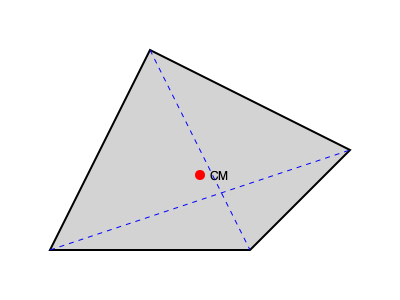An irregularly shaped object is shown above. Two lines are drawn connecting opposite corners. What method can be used to determine the center of mass (CM) of this object, and where would it be located? To determine the center of mass for an irregularly shaped object, we can follow these steps:

1. The method used is the intersection of diagonals for a planar object.

2. For a planar object with uniform density, the center of mass lies at the centroid of the shape.

3. In this case, we draw two lines connecting opposite corners (diagonals) of the irregular quadrilateral.

4. The intersection point of these diagonals represents the centroid, and thus the center of mass, of the object.

5. This method works because:
   a) The centroid of a triangle lies at the intersection of its medians.
   b) A quadrilateral can be divided into two triangles by its diagonal.
   c) The centroids of these two triangles lie on the other diagonal.
   d) Therefore, the intersection of the diagonals gives the overall centroid.

6. In the diagram, we can see that the red dot (labeled CM) is indeed located at the intersection of the two blue dashed lines (diagonals).

This method is particularly useful for simple planar shapes and is often employed in mechanical engineering for quick estimations of the center of mass.
Answer: Intersection of diagonals; at the diagonals' intersection point. 